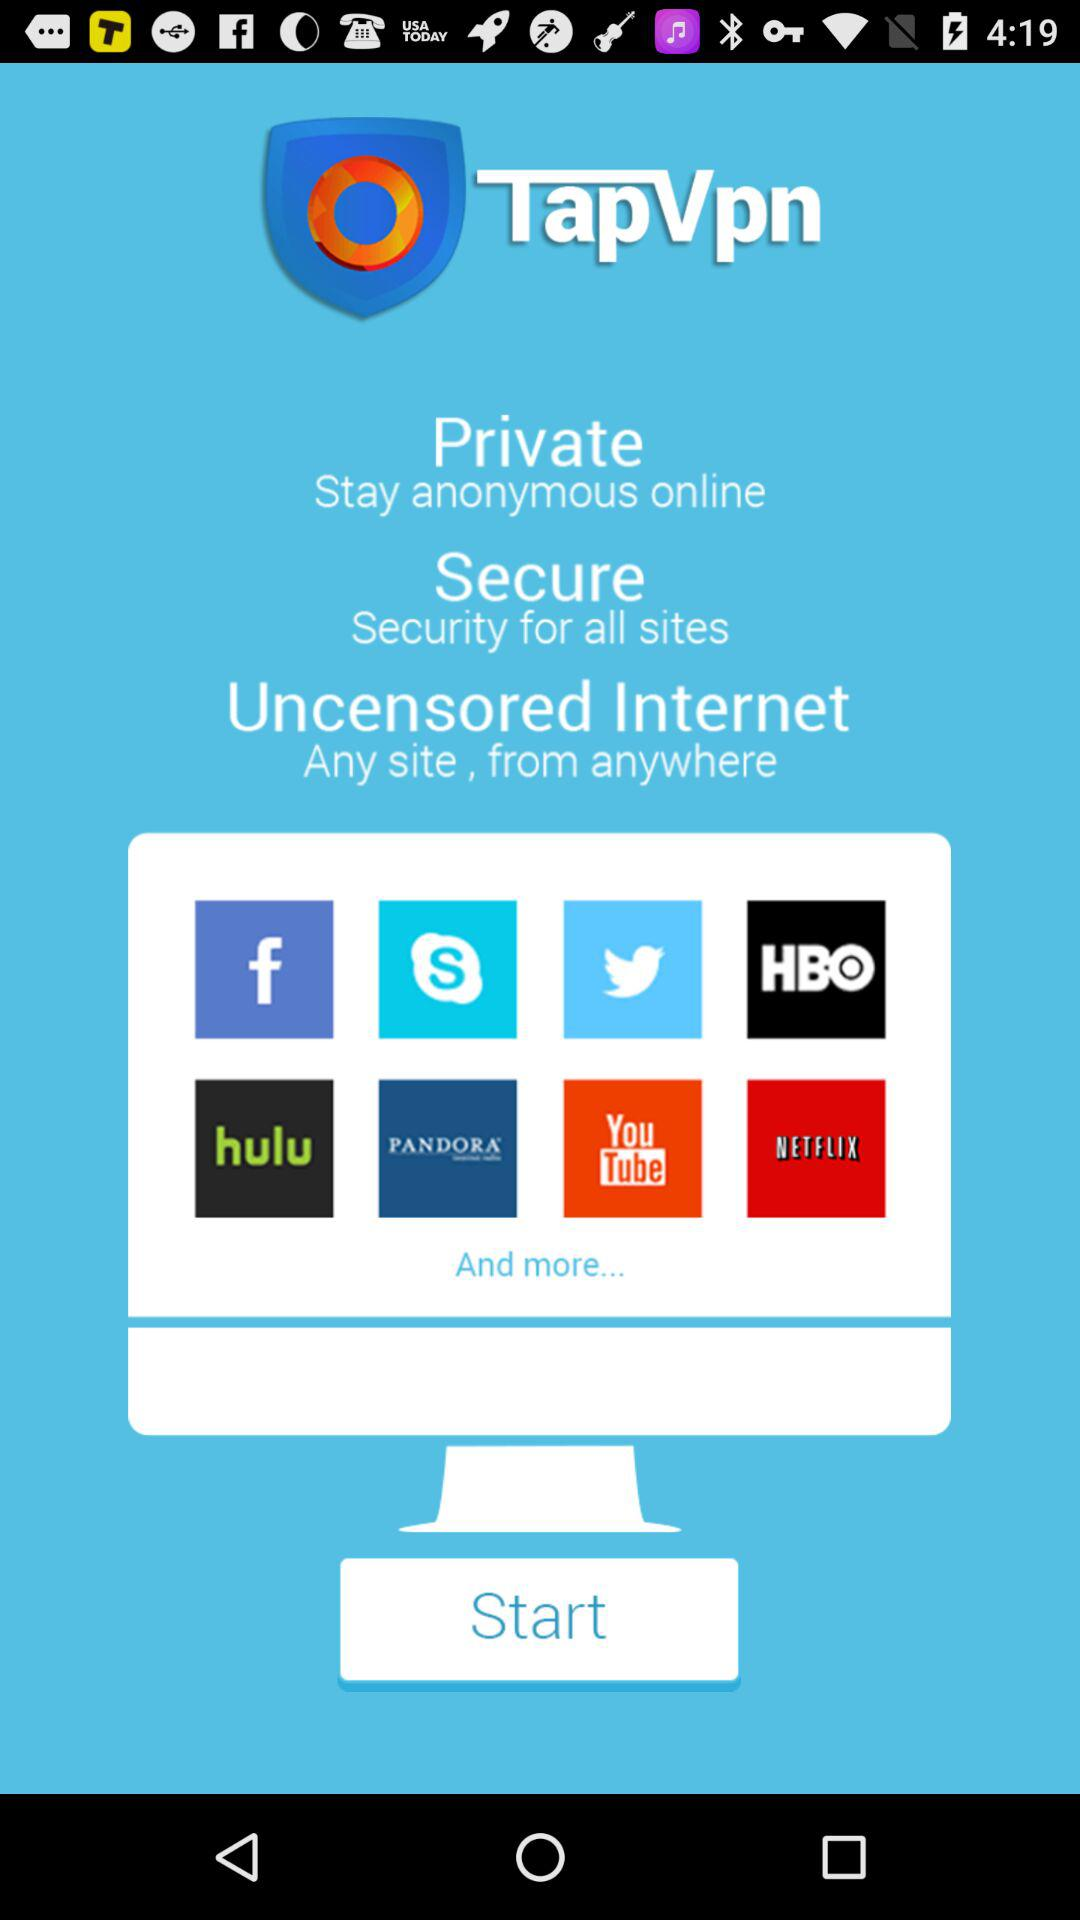What are the VPN's features? The VPN's features are "Private", "Secure" and "Uncensored Internet". 